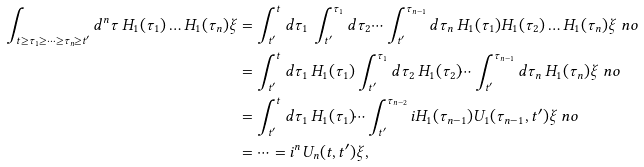<formula> <loc_0><loc_0><loc_500><loc_500>\int _ { t \geq \tau _ { 1 } \geq \dots \geq \tau _ { n } \geq t ^ { \prime } } d ^ { n } \tau \, H _ { 1 } ( \tau _ { 1 } ) \dots H _ { 1 } ( \tau _ { n } ) \xi & = \int _ { t ^ { \prime } } ^ { t } d \tau _ { 1 } \, \int _ { t ^ { \prime } } ^ { \tau _ { 1 } } d \tau _ { 2 } \, \dots \int _ { t ^ { \prime } } ^ { \tau _ { n - 1 } } d \tau _ { n } \, H _ { 1 } ( \tau _ { 1 } ) H _ { 1 } ( \tau _ { 2 } ) \dots H _ { 1 } ( \tau _ { n } ) \xi \ n o \\ & = \int _ { t ^ { \prime } } ^ { t } d \tau _ { 1 } \, H _ { 1 } ( \tau _ { 1 } ) \int _ { t ^ { \prime } } ^ { \tau _ { 1 } } d \tau _ { 2 } \, H _ { 1 } ( \tau _ { 2 } ) \dots \int _ { t ^ { \prime } } ^ { \tau _ { n - 1 } } d \tau _ { n } \, H _ { 1 } ( \tau _ { n } ) \xi \ n o \\ & = \int _ { t ^ { \prime } } ^ { t } d \tau _ { 1 } \, H _ { 1 } ( \tau _ { 1 } ) \dots \int _ { t ^ { \prime } } ^ { \tau _ { n - 2 } } i H _ { 1 } ( \tau _ { n - 1 } ) U _ { 1 } ( \tau _ { n - 1 } , t ^ { \prime } ) \xi \ n o \\ & = \dots = i ^ { n } U _ { n } ( t , t ^ { \prime } ) \xi ,</formula> 